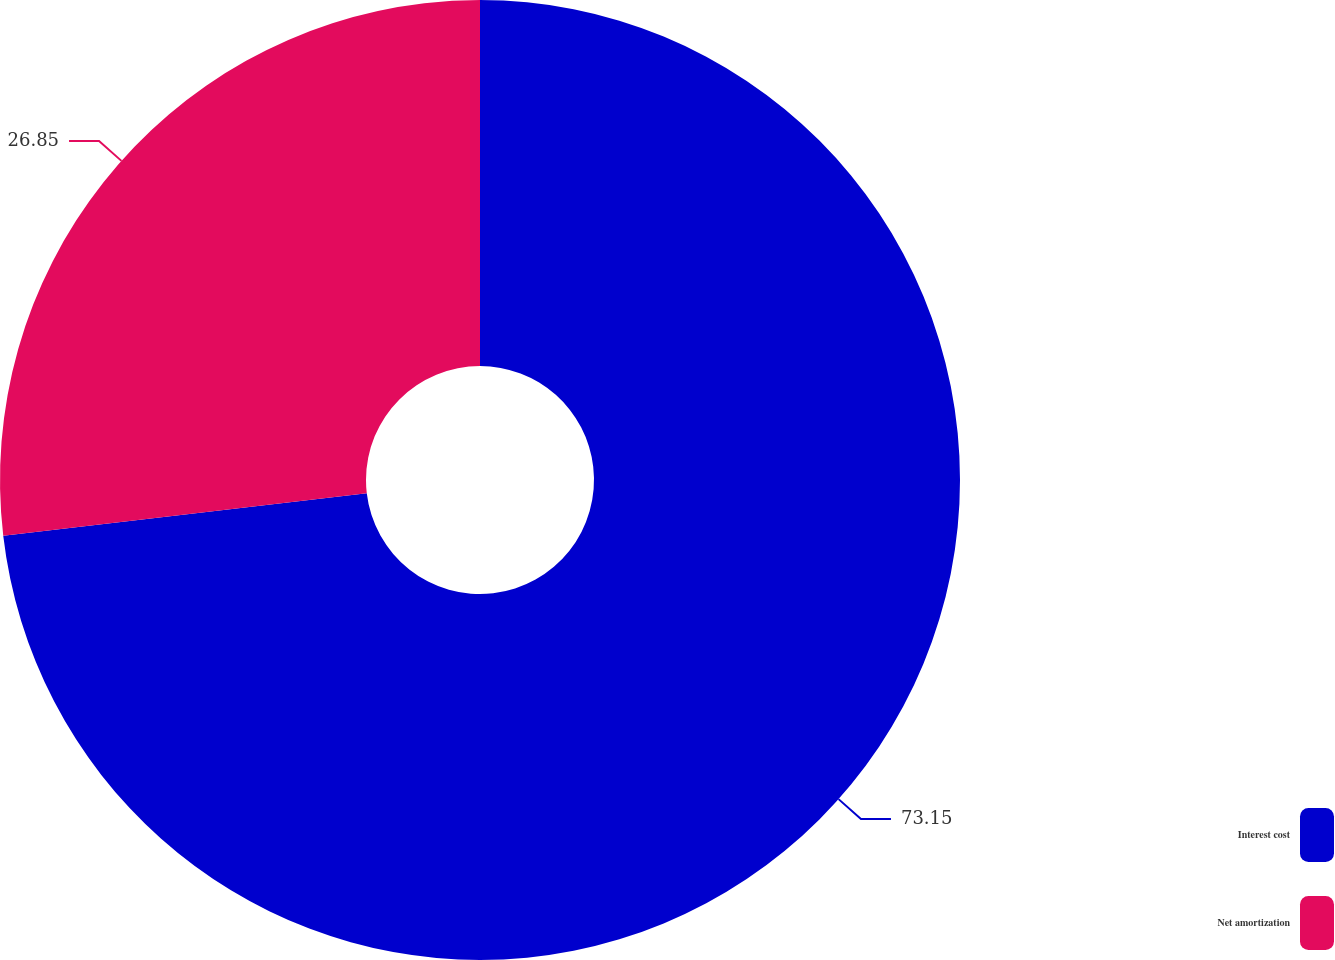Convert chart. <chart><loc_0><loc_0><loc_500><loc_500><pie_chart><fcel>Interest cost<fcel>Net amortization<nl><fcel>73.15%<fcel>26.85%<nl></chart> 